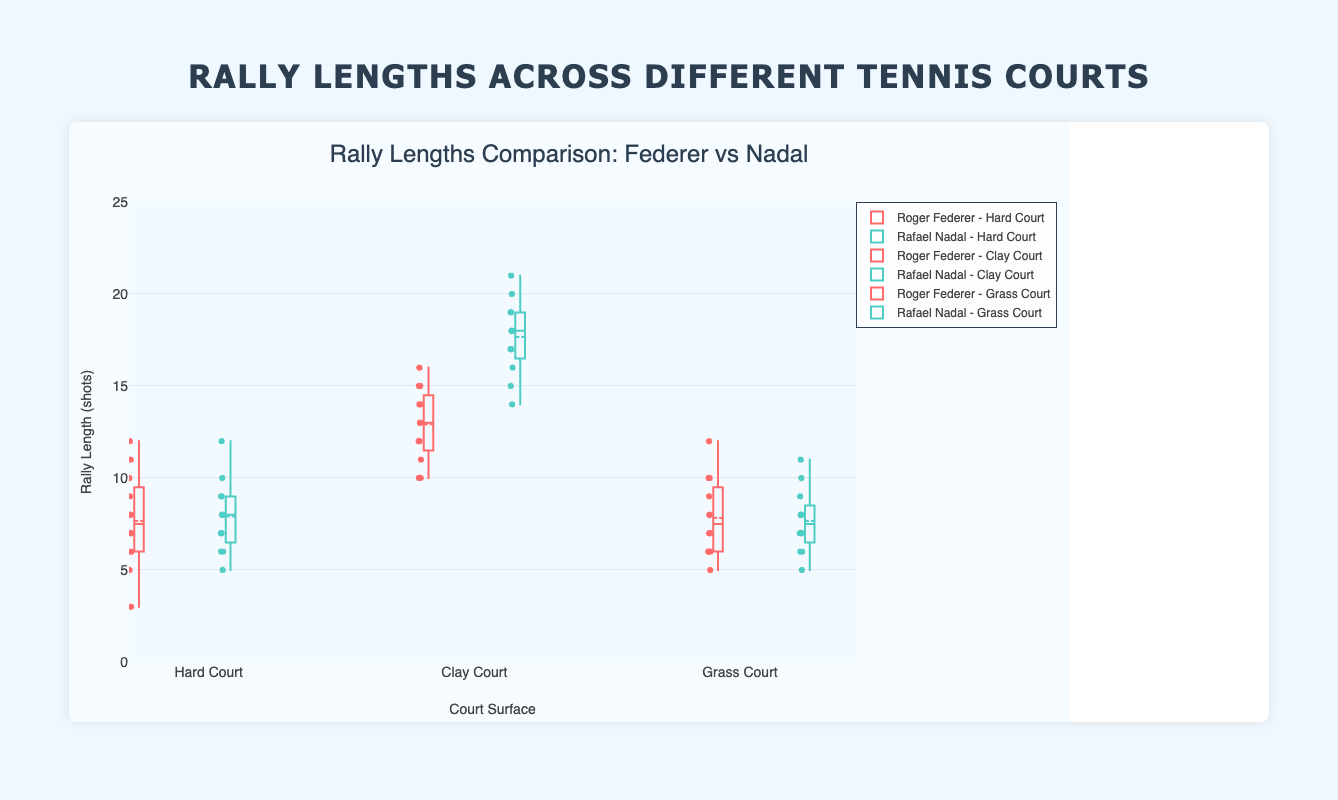What is the title of the plot? At the top of the plot, the text clearly states "Rally Lengths Comparison: Federer vs Nadal".
Answer: Rally Lengths Comparison: Federer vs Nadal What is depicted on the x-axis? The x-axis is labeled "Court Surface" and contains three categories: "Hard Court", "Clay Court", and "Grass Court". This categorizes the data according to the type of court surface.
Answer: Court Surface Compare the median rally lengths of Roger Federer and Rafael Nadal on clay courts. Who has the longer median rally? On clay courts, Roger Federer's box plot has a median value represented by a line within the box, which hovers around 13. Rafael Nadal's median is higher, nearly reaching 18. Thus, Nadal has a longer median rally on clay courts.
Answer: Rafael Nadal Which court surface has the shortest rally lengths for Roger Federer, on average? By examining the median lines in the box plots for Roger Federer across all surfaces, the lowest median is observed on grass courts.
Answer: Grass Court Look at the spread of rally lengths for Rafael Nadal on hard courts. Does he have any data points that might be considered outliers? If yes, how many? On hard courts, Rafael Nadal’s box plot shows some individual points away from the main cluster of data, below 5. This suggests he has outliers. These outliers amount to two points below the whisker.
Answer: Yes, 2 Are the rally lengths more consistent for Roger Federer or Rafael Nadal on grass courts? Checking the box plot's IQR (interquartile range), which indicates consistency, Federer’s range (from about 6 to 10) is slightly narrower than Nadal’s (which covers a similar range). Both ranges are close, but Federer's appears slightly more consistent.
Answer: Roger Federer Compare the mean rally length of both players on clay courts. Which player has the higher mean rally length? The plot includes mean markers within each box plot. For clay courts, Federer’s mean is a bit above 13, while Nadal's mean is significantly higher at roughly 17.
Answer: Rafael Nadal Which type of court shows the greatest variability in rally length for Rafael Nadal? The variability is depicted by the length of the box and whiskers. Rafael Nadal’s clay court has the largest spread from around 14 to 21, indicating the greatest variability.
Answer: Clay Court 